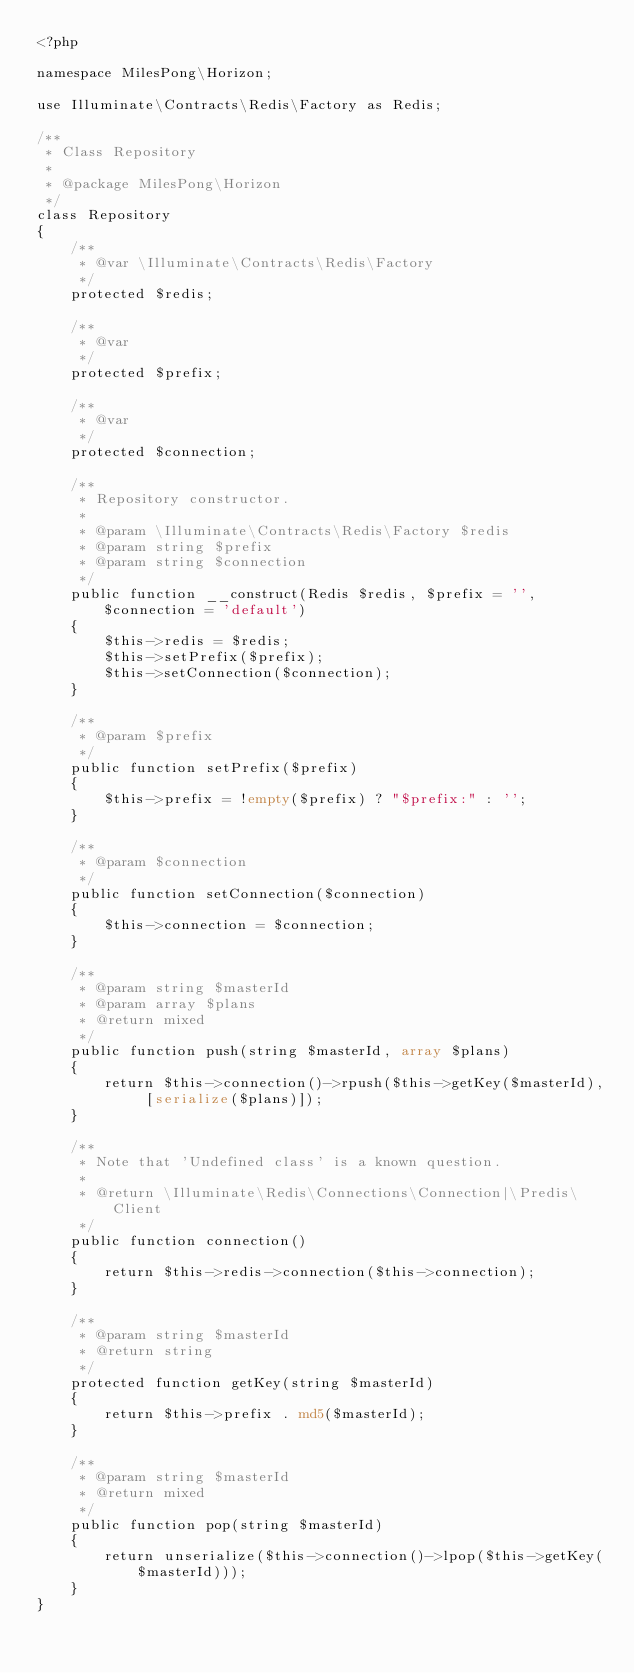<code> <loc_0><loc_0><loc_500><loc_500><_PHP_><?php

namespace MilesPong\Horizon;

use Illuminate\Contracts\Redis\Factory as Redis;

/**
 * Class Repository
 *
 * @package MilesPong\Horizon
 */
class Repository
{
    /**
     * @var \Illuminate\Contracts\Redis\Factory
     */
    protected $redis;

    /**
     * @var
     */
    protected $prefix;

    /**
     * @var
     */
    protected $connection;

    /**
     * Repository constructor.
     *
     * @param \Illuminate\Contracts\Redis\Factory $redis
     * @param string $prefix
     * @param string $connection
     */
    public function __construct(Redis $redis, $prefix = '', $connection = 'default')
    {
        $this->redis = $redis;
        $this->setPrefix($prefix);
        $this->setConnection($connection);
    }

    /**
     * @param $prefix
     */
    public function setPrefix($prefix)
    {
        $this->prefix = !empty($prefix) ? "$prefix:" : '';
    }

    /**
     * @param $connection
     */
    public function setConnection($connection)
    {
        $this->connection = $connection;
    }

    /**
     * @param string $masterId
     * @param array $plans
     * @return mixed
     */
    public function push(string $masterId, array $plans)
    {
        return $this->connection()->rpush($this->getKey($masterId), [serialize($plans)]);
    }

    /**
     * Note that 'Undefined class' is a known question.
     *
     * @return \Illuminate\Redis\Connections\Connection|\Predis\Client
     */
    public function connection()
    {
        return $this->redis->connection($this->connection);
    }

    /**
     * @param string $masterId
     * @return string
     */
    protected function getKey(string $masterId)
    {
        return $this->prefix . md5($masterId);
    }

    /**
     * @param string $masterId
     * @return mixed
     */
    public function pop(string $masterId)
    {
        return unserialize($this->connection()->lpop($this->getKey($masterId)));
    }
}
</code> 